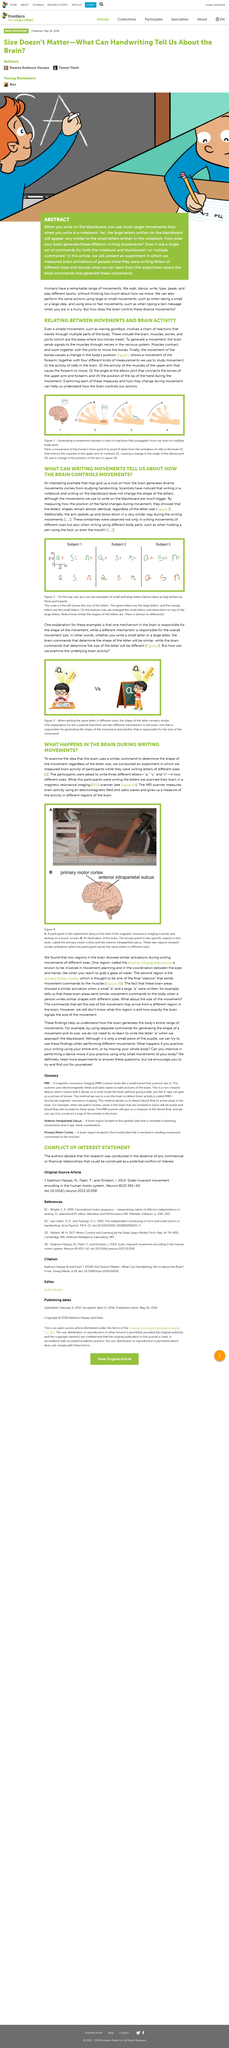Specify some key components in this picture. An MRI scanner was used to scan the brains of participants while they wrote letters. An MRI scanner measures brain activity by producing a strong magnetic field, which aligns hydrogen atoms in the body. Radio waves are then sent through the body, causing the nuclei of these aligned atoms to emit signals that are detected by the scanner, providing detailed information about the brain's activity. The experiment measured brain activations in people while they were writing. The brain is responsible for generating commands for different writing movements. During the experiment, people wrote letters of varying sizes. 